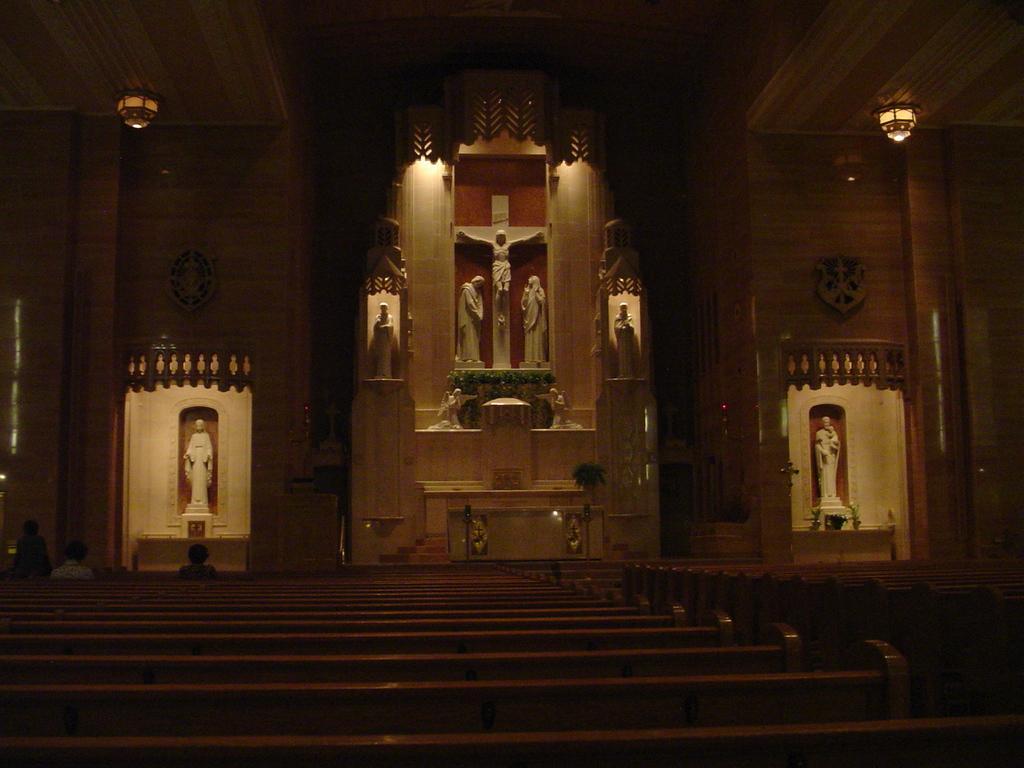How would you summarize this image in a sentence or two? In this image, there is a church contains some sculptures. There is a light in the top left and in the top right of the image. There are benches at the bottom of the image. 